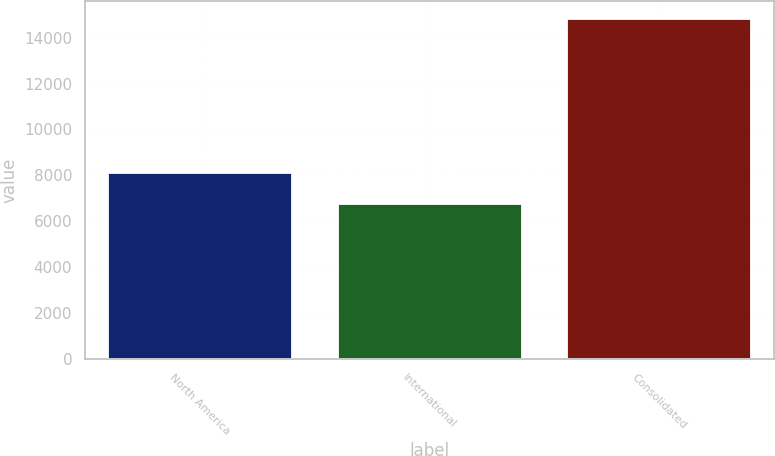Convert chart. <chart><loc_0><loc_0><loc_500><loc_500><bar_chart><fcel>North America<fcel>International<fcel>Consolidated<nl><fcel>8095<fcel>6740<fcel>14835<nl></chart> 